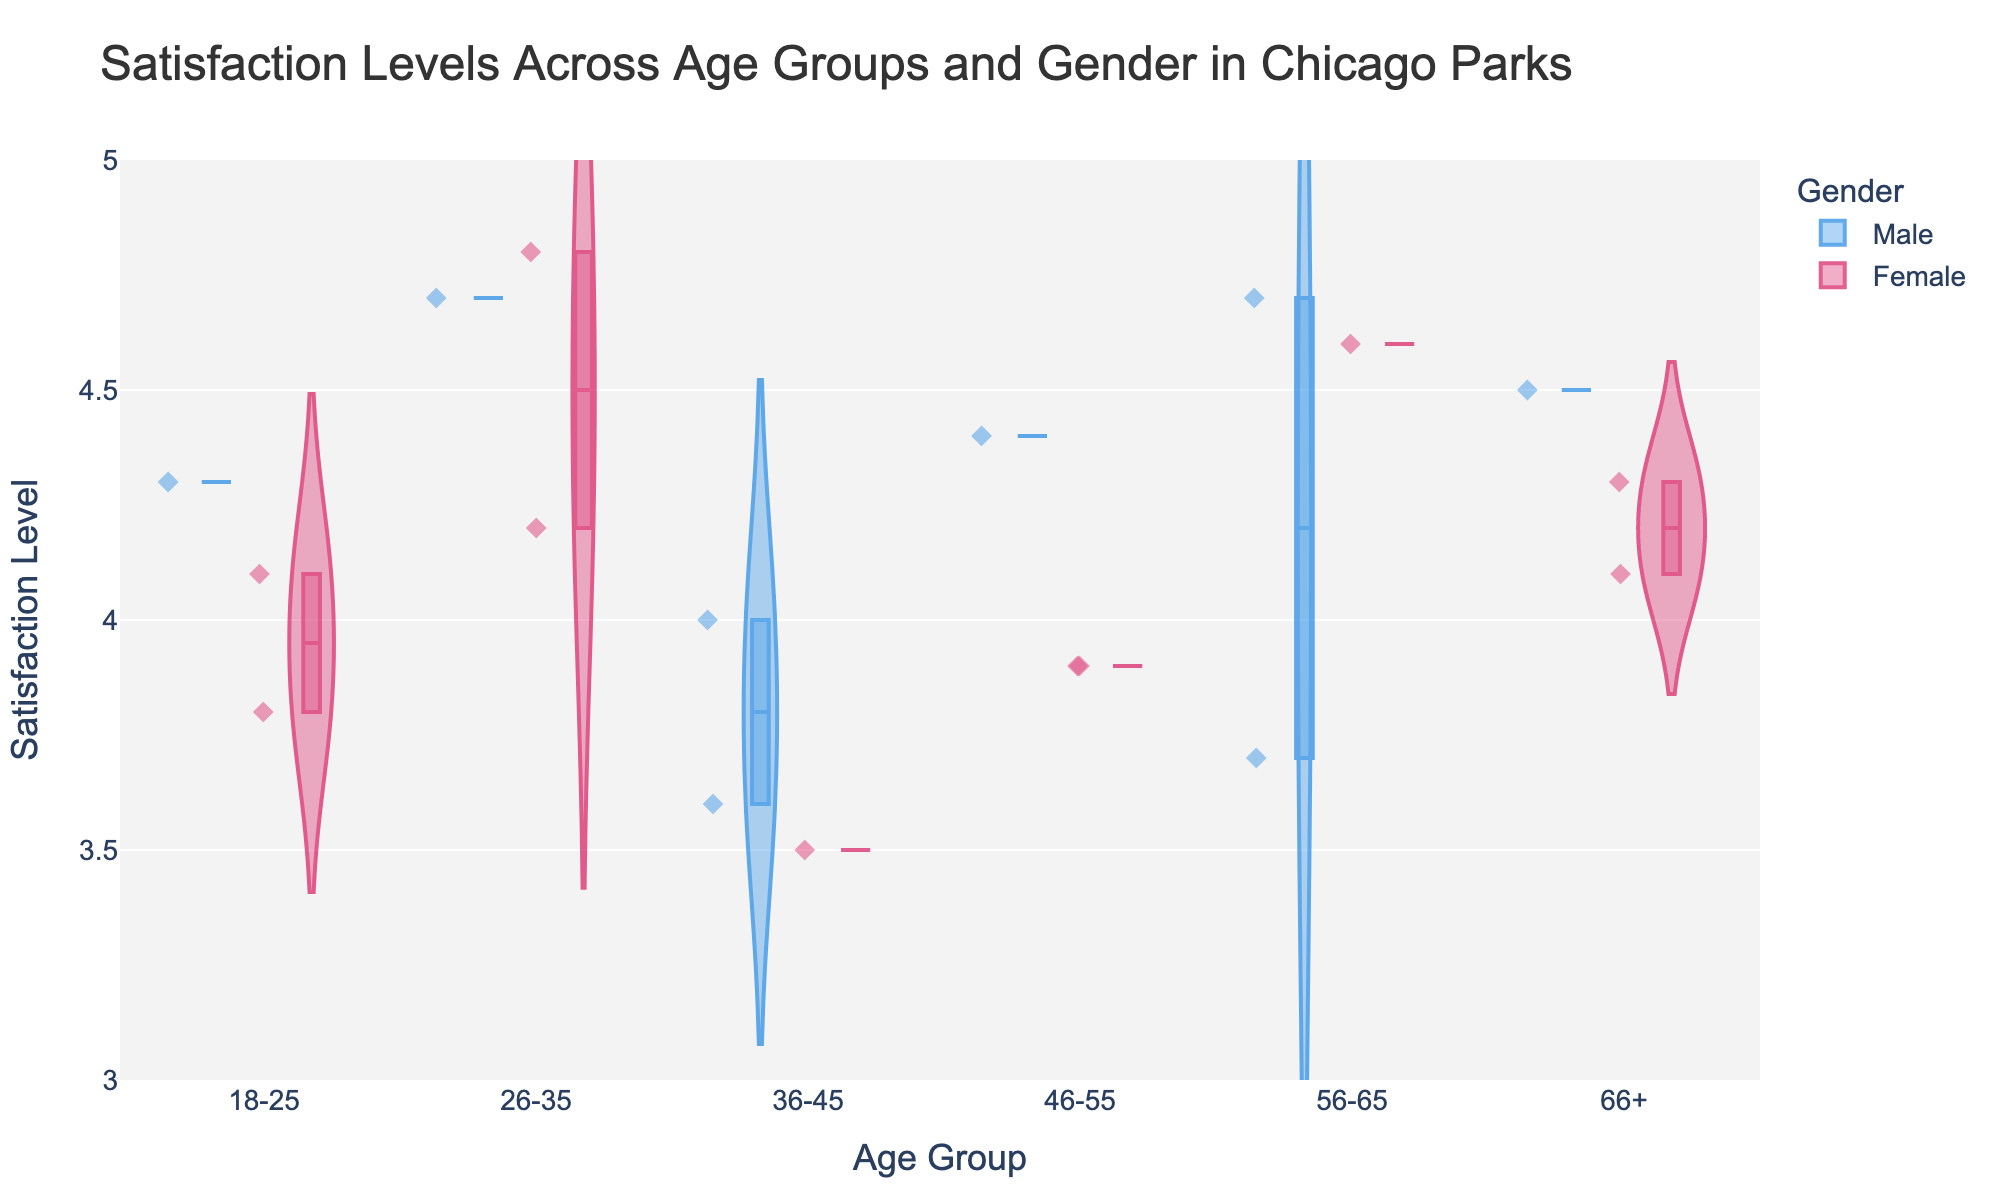What is the title of the figure? The title is located at the top of the figure and helps identify the main topic being visualized.
Answer: Satisfaction Levels Across Age Groups and Gender in Chicago Parks Which age group has the widest distribution of satisfaction levels? By looking at the width of the violin plots for each age group, the group with the widest spread can be identified.
Answer: 26-35 What is the median satisfaction level for the age group 56-65? Each violin plot includes a box plot within it, which shows the median line. For the age group 56-65, find this line.
Answer: 4.6 Which gender shows higher satisfaction levels in the age group 18-25? Compare the positions of the violin plots for Male and Female within the age group 18-25. The plot that is generally positioned higher indicates higher satisfaction.
Answer: Male What is the highest recorded satisfaction level among all groups? By scanning across the violin plots, the highest point reached in any of the plots will indicate the highest satisfaction level.
Answer: 4.8 Which age group has the lowest median satisfaction level, and what is that level? Look at the median lines in the box plots within each violin plot to find the lowest one.
Answer: 36-45, 3.5 Compare the median satisfaction levels between the age groups 46-55 and 66+ for females. Which group has a higher median and by how much? Identify the median lines for females in both age groups and note their values. Calculate the difference.
Answer: 46-55 has higher by 0.2 Are there any outliers in the satisfaction levels for the age group 36-45? Outliers are usually indicated by points that lie outside the main body of the violin plot. Check the age group 36-45 for any such points.
Answer: Yes What is the average satisfaction level for males in the age group 46-55? Identify the individual points for males in the age group 46-55, sum them up and divide by the number of points.
Answer: 4.4 Which group has the tightest distribution around the median satisfaction level? A tight distribution will have less spread around the median line within the violin plot. Identify the group with the least spread.
Answer: 56-65 